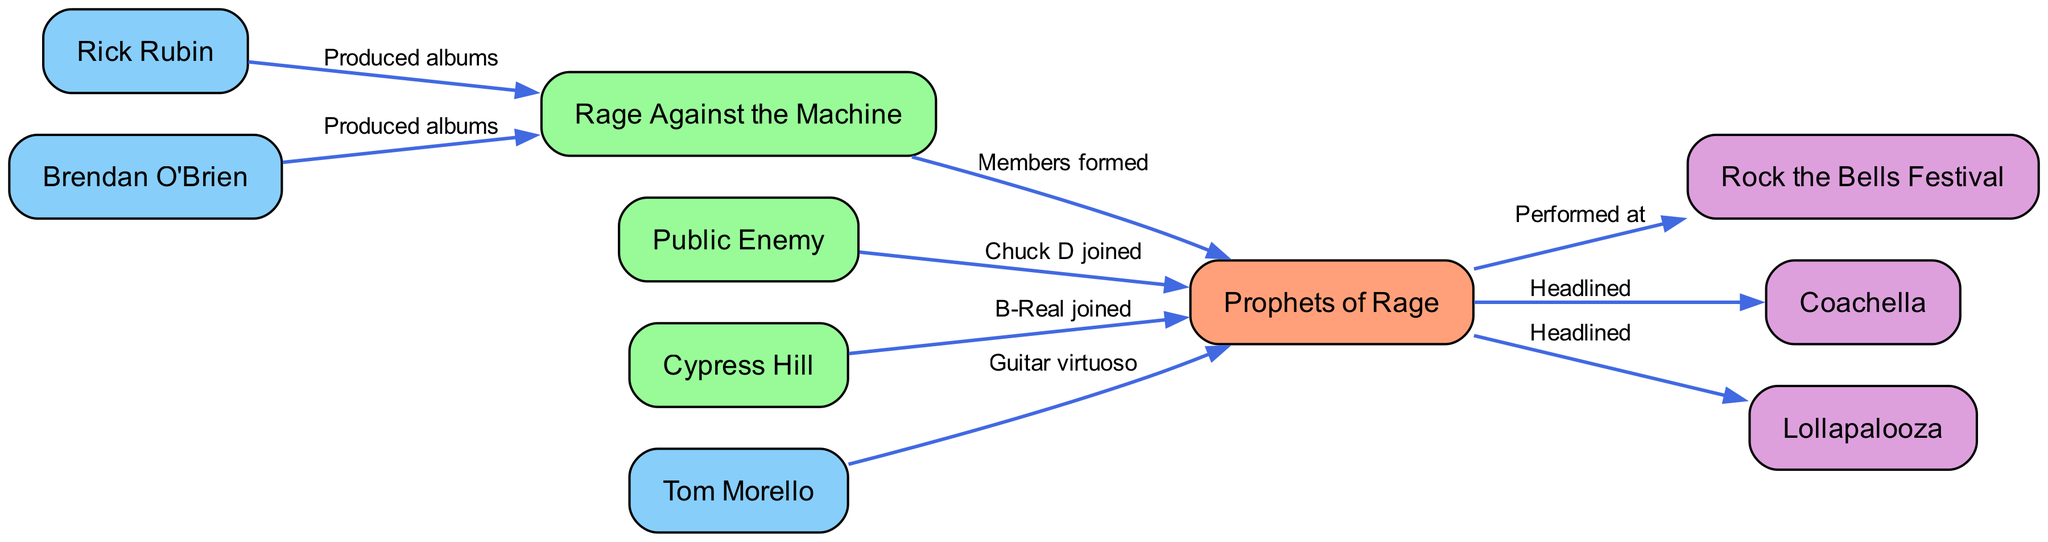What band formed Prophets of Rage? The diagram shows an edge from Rage Against the Machine to Prophets of Rage labeled "Members formed," indicating that members of Rage Against the Machine formed Prophets of Rage.
Answer: Rage Against the Machine Who produced albums for Rage Against the Machine? The diagram indicates two edges leading from Rick Rubin and Brendan O'Brien to Rage Against the Machine, both labeled "Produced albums."
Answer: Rick Rubin and Brendan O'Brien How many bands are connected to Prophets of Rage? By counting the edges originating from Prophets of Rage to other nodes, we see it connects to Rock the Bells Festival, Coachella, and Lollapalooza, which totals three outgoing edges.
Answer: 3 Which artist is connected to Prophets of Rage as a guitar virtuoso? The edge from Tom Morello to Prophets of Rage labeled "Guitar virtuoso" shows this relationship.
Answer: Tom Morello What festival did Prophets of Rage headline? The diagram shows an edge from Prophets of Rage to Coachella with the label "Headlined," indicating they headlined that festival.
Answer: Coachella Which band influenced Prophets of Rage through Chuck D? The diagram shows an edge from Public Enemy to Prophets of Rage with the label "Chuck D joined," indicating the influence from Public Enemy.
Answer: Public Enemy How many total nodes are there in the diagram? By counting all unique nodes listed in the nodes section of the diagram, there are ten nodes in total.
Answer: 10 What relationship does Cypress Hill have with Prophets of Rage? The edge from Cypress Hill to Prophets of Rage labeled "B-Real joined" indicates that Cypress Hill has a connection through B-Real joining the band.
Answer: B-Real joined What is the connection from Prophets of Rage to Rock the Bells Festival? The edge from Prophets of Rage to Rock the Bells Festival labeled "Performed at" indicates that they performed there.
Answer: Performed at 